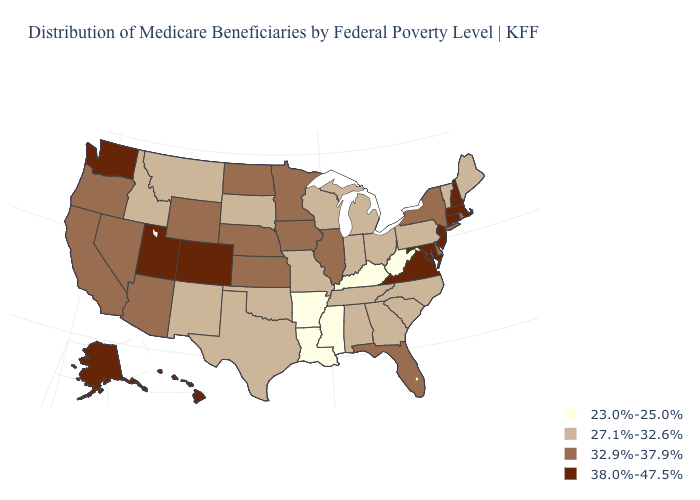What is the highest value in the USA?
Give a very brief answer. 38.0%-47.5%. What is the highest value in the USA?
Give a very brief answer. 38.0%-47.5%. What is the value of Ohio?
Concise answer only. 27.1%-32.6%. Does Wisconsin have the highest value in the USA?
Be succinct. No. Does the map have missing data?
Give a very brief answer. No. Does the map have missing data?
Answer briefly. No. Name the states that have a value in the range 32.9%-37.9%?
Quick response, please. Arizona, California, Delaware, Florida, Illinois, Iowa, Kansas, Minnesota, Nebraska, Nevada, New York, North Dakota, Oregon, Rhode Island, Wyoming. What is the value of Delaware?
Keep it brief. 32.9%-37.9%. What is the value of Wisconsin?
Keep it brief. 27.1%-32.6%. What is the value of Montana?
Be succinct. 27.1%-32.6%. Which states hav the highest value in the Northeast?
Answer briefly. Connecticut, Massachusetts, New Hampshire, New Jersey. What is the value of Nebraska?
Short answer required. 32.9%-37.9%. Which states have the highest value in the USA?
Give a very brief answer. Alaska, Colorado, Connecticut, Hawaii, Maryland, Massachusetts, New Hampshire, New Jersey, Utah, Virginia, Washington. Does Arkansas have a lower value than Wyoming?
Write a very short answer. Yes. Does Maine have the lowest value in the Northeast?
Short answer required. Yes. 